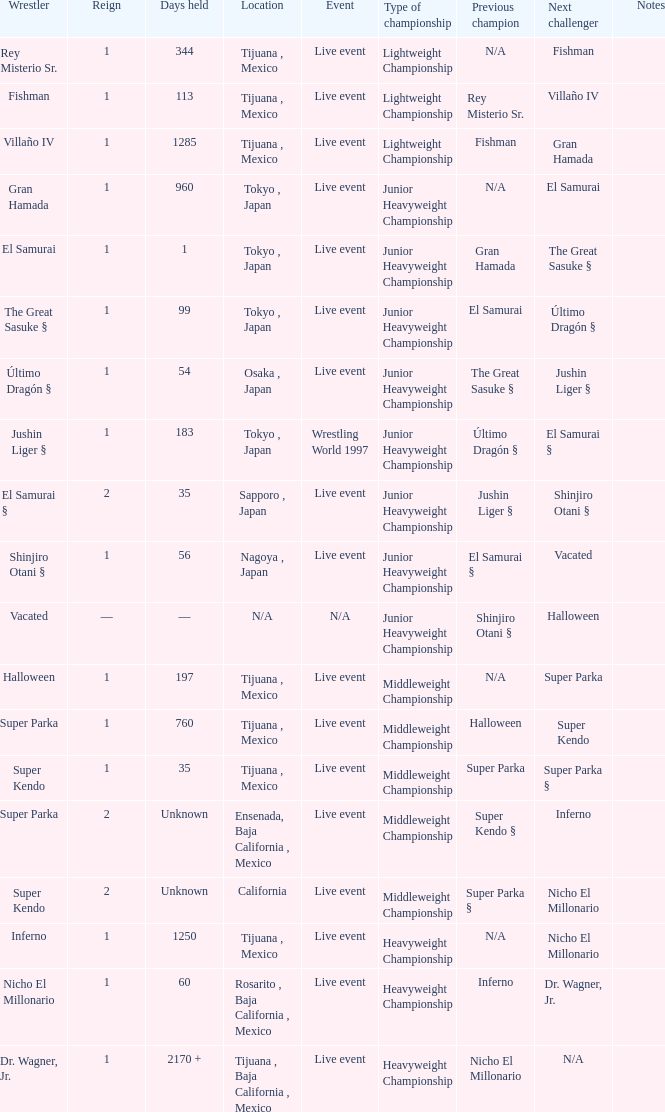Where did the wrestler, super parka, with the title with a reign of 2? Ensenada, Baja California , Mexico. 